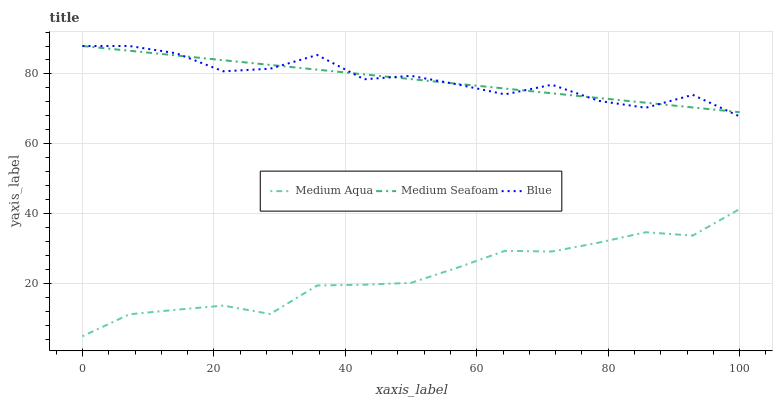Does Medium Seafoam have the minimum area under the curve?
Answer yes or no. No. Does Medium Seafoam have the maximum area under the curve?
Answer yes or no. No. Is Medium Aqua the smoothest?
Answer yes or no. No. Is Medium Aqua the roughest?
Answer yes or no. No. Does Medium Seafoam have the lowest value?
Answer yes or no. No. Does Medium Aqua have the highest value?
Answer yes or no. No. Is Medium Aqua less than Blue?
Answer yes or no. Yes. Is Blue greater than Medium Aqua?
Answer yes or no. Yes. Does Medium Aqua intersect Blue?
Answer yes or no. No. 